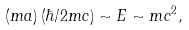<formula> <loc_0><loc_0><loc_500><loc_500>\left ( m a \right ) \left ( \hbar { / } 2 m c \right ) \sim E \sim m c ^ { 2 } ,</formula> 